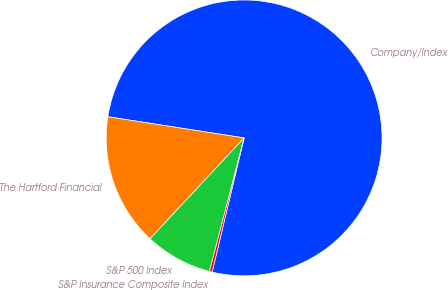Convert chart. <chart><loc_0><loc_0><loc_500><loc_500><pie_chart><fcel>Company/Index<fcel>The Hartford Financial<fcel>S&P 500 Index<fcel>S&P Insurance Composite Index<nl><fcel>76.27%<fcel>15.51%<fcel>7.91%<fcel>0.31%<nl></chart> 